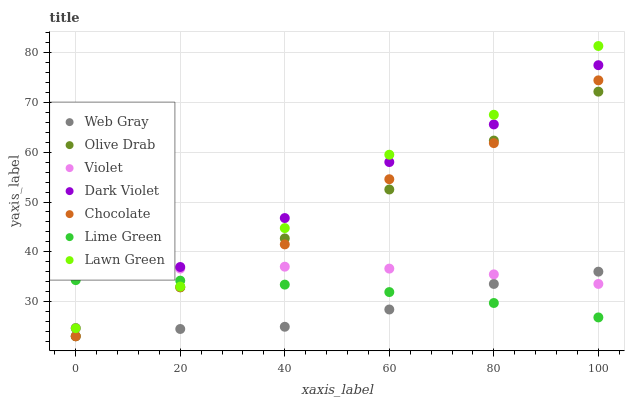Does Web Gray have the minimum area under the curve?
Answer yes or no. Yes. Does Dark Violet have the maximum area under the curve?
Answer yes or no. Yes. Does Dark Violet have the minimum area under the curve?
Answer yes or no. No. Does Web Gray have the maximum area under the curve?
Answer yes or no. No. Is Olive Drab the smoothest?
Answer yes or no. Yes. Is Lawn Green the roughest?
Answer yes or no. Yes. Is Web Gray the smoothest?
Answer yes or no. No. Is Web Gray the roughest?
Answer yes or no. No. Does Web Gray have the lowest value?
Answer yes or no. Yes. Does Dark Violet have the lowest value?
Answer yes or no. No. Does Lawn Green have the highest value?
Answer yes or no. Yes. Does Web Gray have the highest value?
Answer yes or no. No. Is Chocolate less than Dark Violet?
Answer yes or no. Yes. Is Lawn Green greater than Chocolate?
Answer yes or no. Yes. Does Web Gray intersect Chocolate?
Answer yes or no. Yes. Is Web Gray less than Chocolate?
Answer yes or no. No. Is Web Gray greater than Chocolate?
Answer yes or no. No. Does Chocolate intersect Dark Violet?
Answer yes or no. No. 